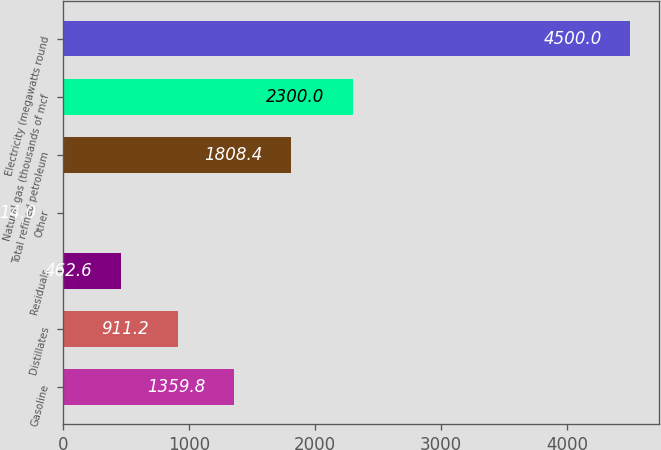<chart> <loc_0><loc_0><loc_500><loc_500><bar_chart><fcel>Gasoline<fcel>Distillates<fcel>Residuals<fcel>Other<fcel>Total refined petroleum<fcel>Natural gas (thousands of mcf<fcel>Electricity (megawatts round<nl><fcel>1359.8<fcel>911.2<fcel>462.6<fcel>14<fcel>1808.4<fcel>2300<fcel>4500<nl></chart> 